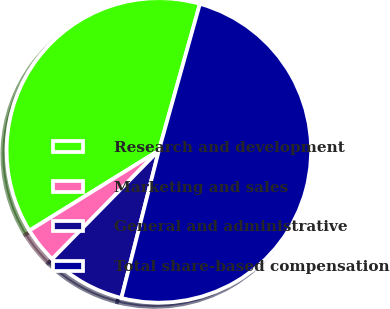Convert chart to OTSL. <chart><loc_0><loc_0><loc_500><loc_500><pie_chart><fcel>Research and development<fcel>Marketing and sales<fcel>General and administrative<fcel>Total share-based compensation<nl><fcel>38.17%<fcel>3.82%<fcel>8.4%<fcel>49.62%<nl></chart> 